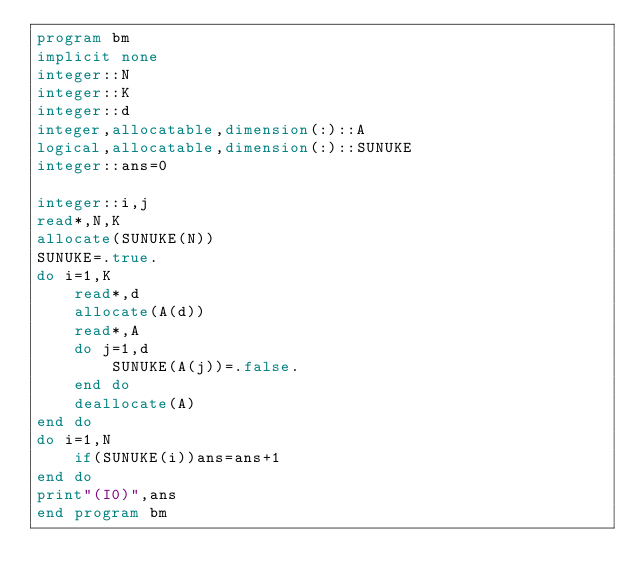Convert code to text. <code><loc_0><loc_0><loc_500><loc_500><_FORTRAN_>program bm
implicit none
integer::N
integer::K
integer::d
integer,allocatable,dimension(:)::A
logical,allocatable,dimension(:)::SUNUKE
integer::ans=0

integer::i,j
read*,N,K
allocate(SUNUKE(N))
SUNUKE=.true.
do i=1,K
    read*,d
    allocate(A(d))
    read*,A
    do j=1,d
        SUNUKE(A(j))=.false.
    end do
    deallocate(A)
end do
do i=1,N
    if(SUNUKE(i))ans=ans+1
end do
print"(I0)",ans
end program bm</code> 